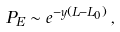<formula> <loc_0><loc_0><loc_500><loc_500>P _ { E } \sim e ^ { - y ( L - L _ { 0 } ) } \, ,</formula> 